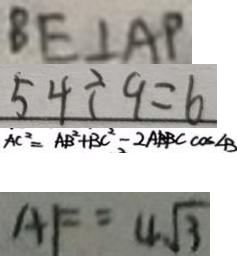Convert formula to latex. <formula><loc_0><loc_0><loc_500><loc_500>B E \bot A P 
 5 4 \div 9 = 6 
 A C ^ { 2 } = A B ^ { 2 } + B C ^ { 2 } - 2 A B B C \cos \angle B 
 A F = 4 \sqrt { 3 }</formula> 